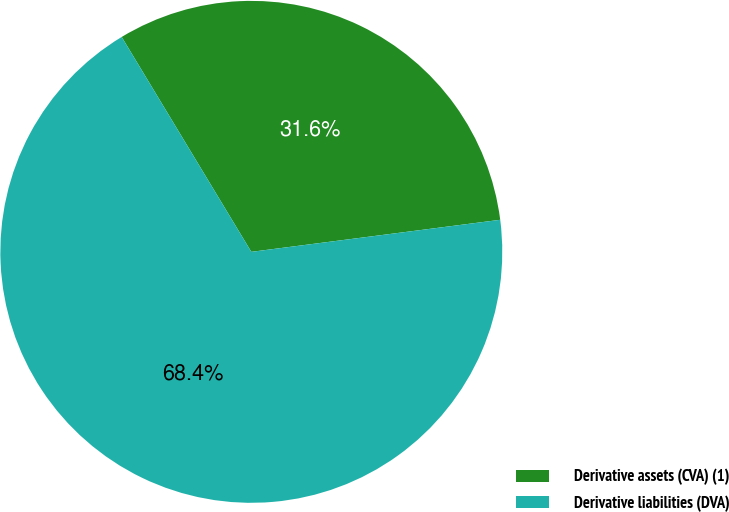Convert chart. <chart><loc_0><loc_0><loc_500><loc_500><pie_chart><fcel>Derivative assets (CVA) (1)<fcel>Derivative liabilities (DVA)<nl><fcel>31.6%<fcel>68.4%<nl></chart> 